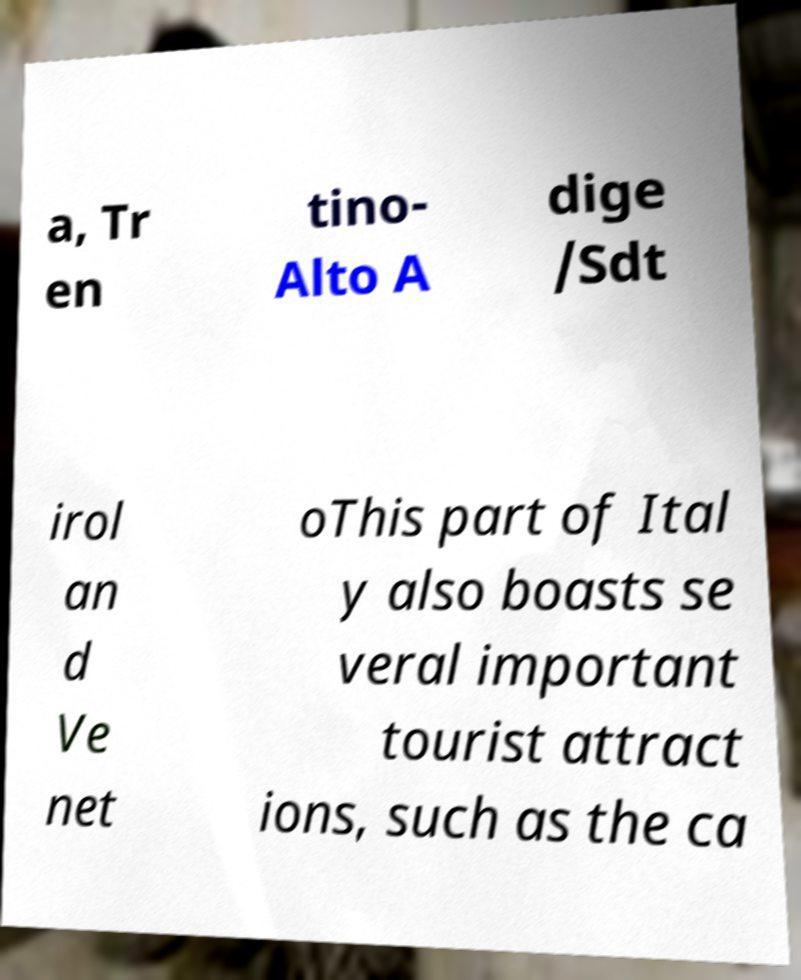Could you assist in decoding the text presented in this image and type it out clearly? a, Tr en tino- Alto A dige /Sdt irol an d Ve net oThis part of Ital y also boasts se veral important tourist attract ions, such as the ca 